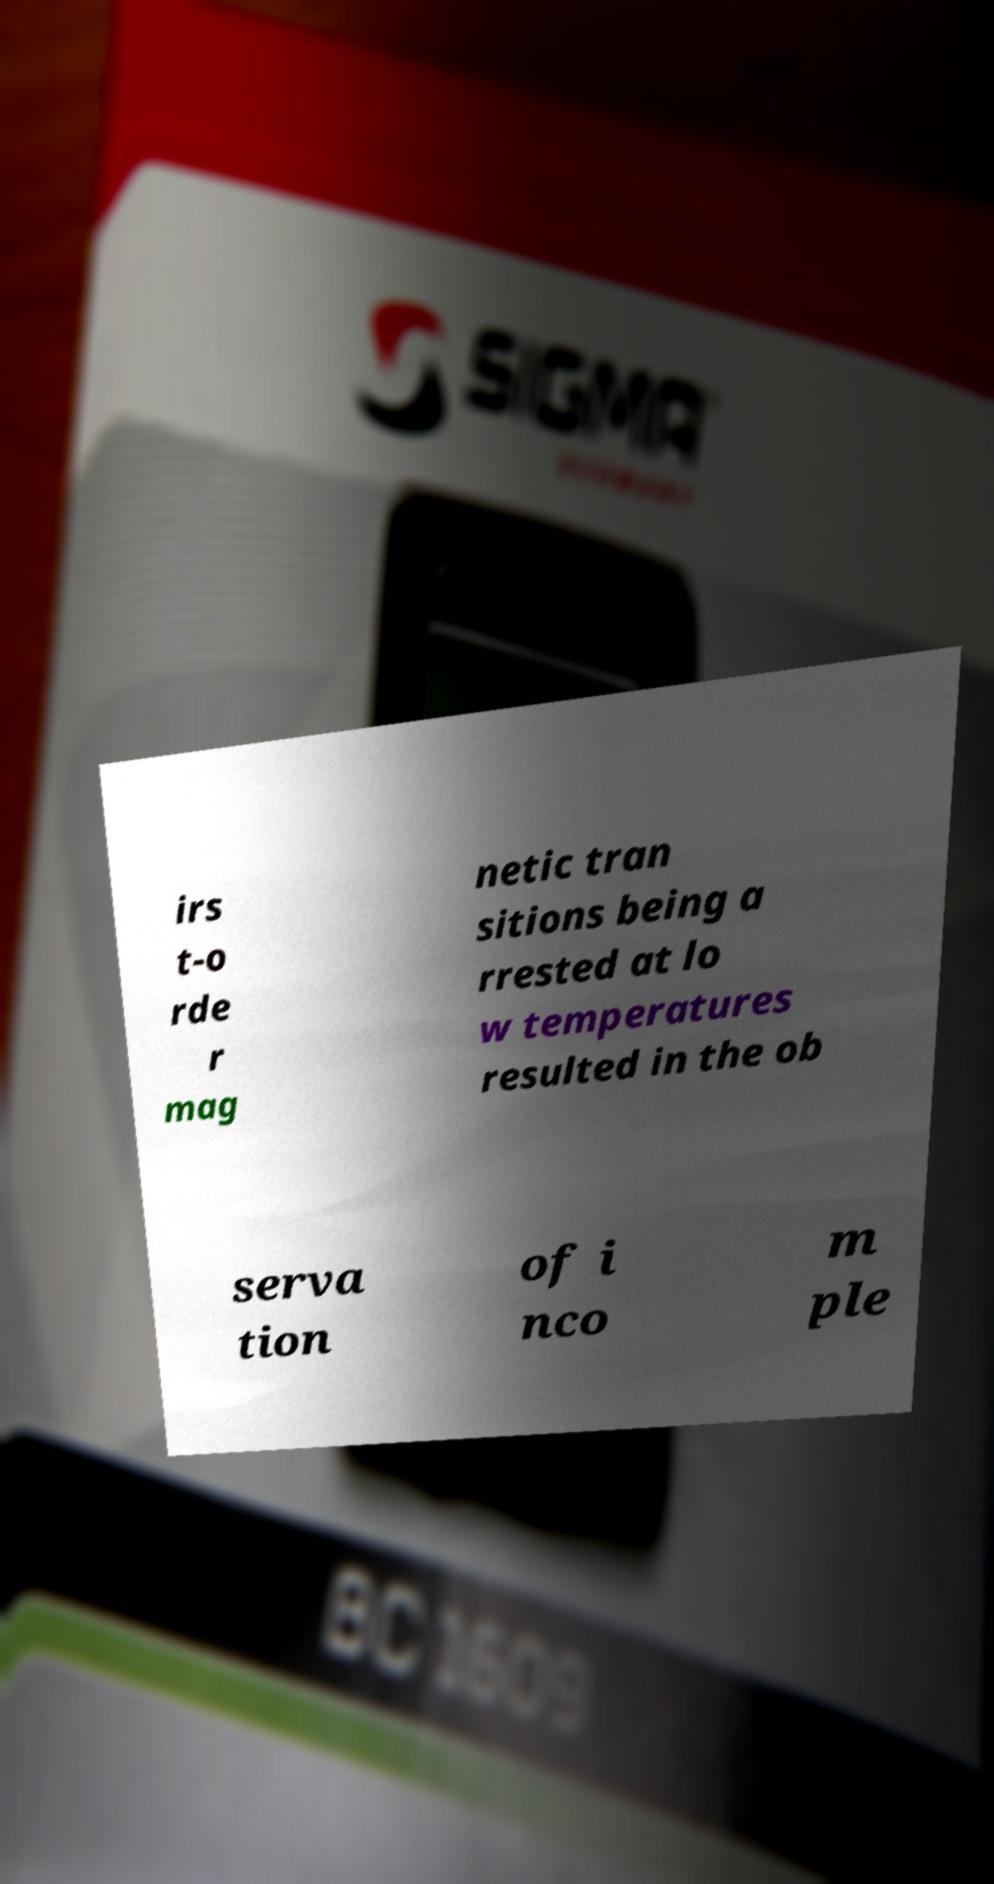What messages or text are displayed in this image? I need them in a readable, typed format. irs t-o rde r mag netic tran sitions being a rrested at lo w temperatures resulted in the ob serva tion of i nco m ple 